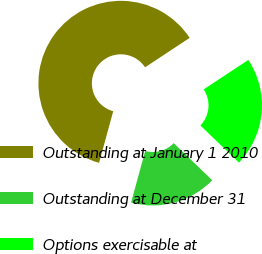Convert chart to OTSL. <chart><loc_0><loc_0><loc_500><loc_500><pie_chart><fcel>Outstanding at January 1 2010<fcel>Outstanding at December 31<fcel>Options exercisable at<nl><fcel>61.46%<fcel>17.05%<fcel>21.49%<nl></chart> 